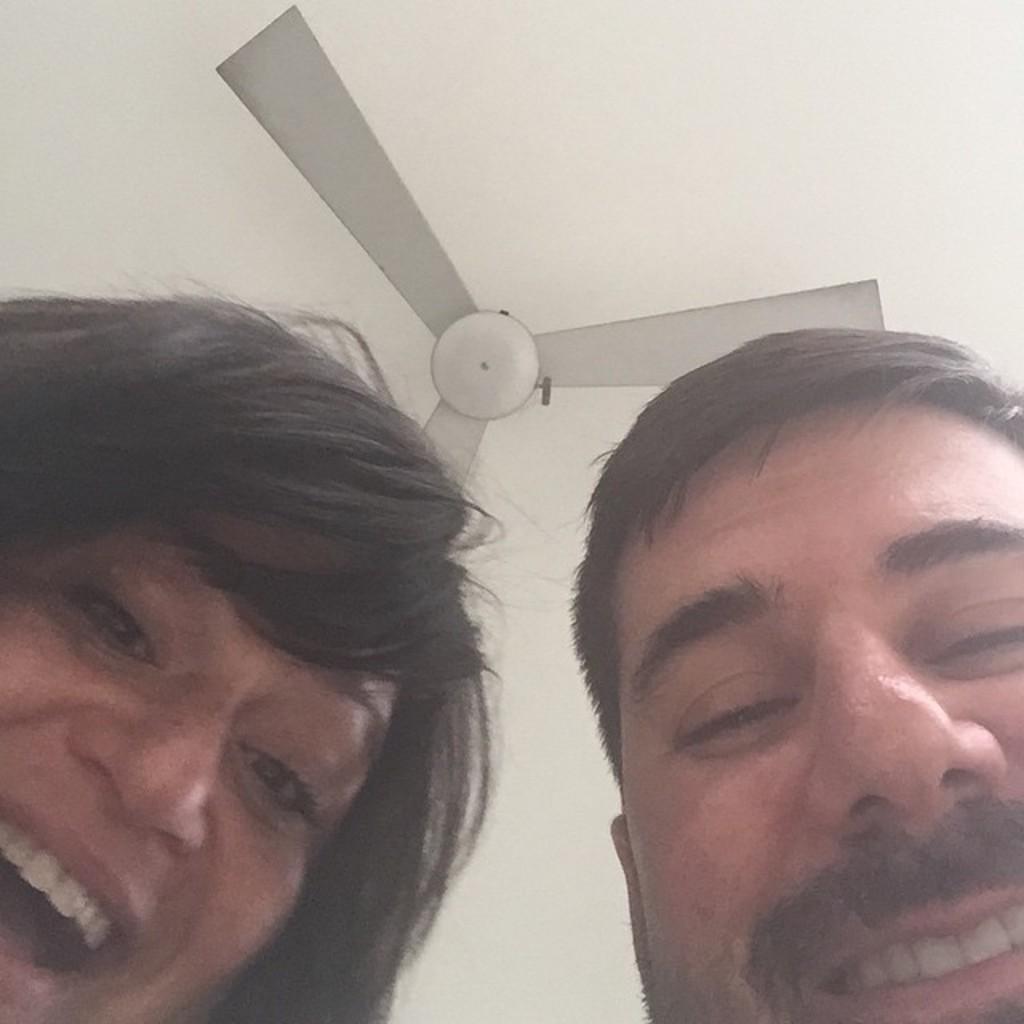In one or two sentences, can you explain what this image depicts? On the left side, there is a woman smiling. On the right side, there is a person smiling. In the background, there is a fan attached to a ceiling. And the background is white in color. 